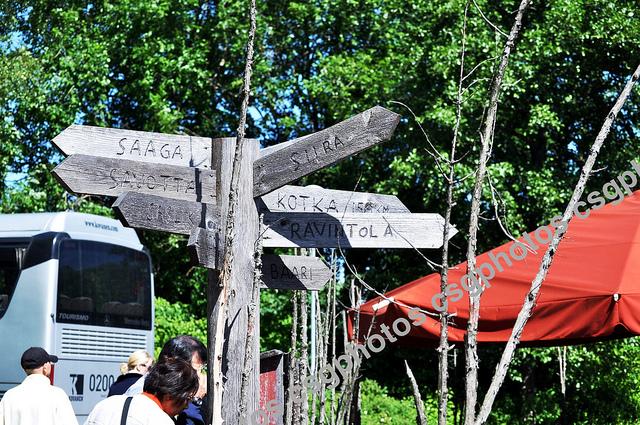How many signs are posted to the post?
Keep it brief. 9. Is this Mexico?
Keep it brief. No. What kind of vehicle is in the photo?
Concise answer only. Bus. 